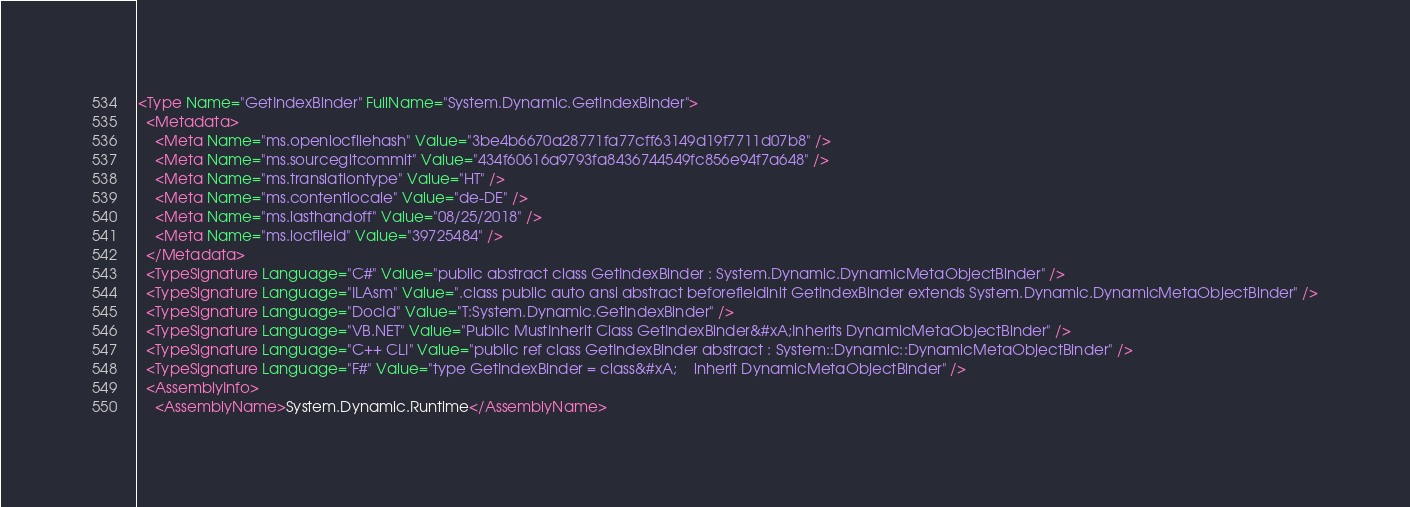Convert code to text. <code><loc_0><loc_0><loc_500><loc_500><_XML_><Type Name="GetIndexBinder" FullName="System.Dynamic.GetIndexBinder">
  <Metadata>
    <Meta Name="ms.openlocfilehash" Value="3be4b6670a28771fa77cff63149d19f7711d07b8" />
    <Meta Name="ms.sourcegitcommit" Value="434f60616a9793fa8436744549fc856e94f7a648" />
    <Meta Name="ms.translationtype" Value="HT" />
    <Meta Name="ms.contentlocale" Value="de-DE" />
    <Meta Name="ms.lasthandoff" Value="08/25/2018" />
    <Meta Name="ms.locfileid" Value="39725484" />
  </Metadata>
  <TypeSignature Language="C#" Value="public abstract class GetIndexBinder : System.Dynamic.DynamicMetaObjectBinder" />
  <TypeSignature Language="ILAsm" Value=".class public auto ansi abstract beforefieldinit GetIndexBinder extends System.Dynamic.DynamicMetaObjectBinder" />
  <TypeSignature Language="DocId" Value="T:System.Dynamic.GetIndexBinder" />
  <TypeSignature Language="VB.NET" Value="Public MustInherit Class GetIndexBinder&#xA;Inherits DynamicMetaObjectBinder" />
  <TypeSignature Language="C++ CLI" Value="public ref class GetIndexBinder abstract : System::Dynamic::DynamicMetaObjectBinder" />
  <TypeSignature Language="F#" Value="type GetIndexBinder = class&#xA;    inherit DynamicMetaObjectBinder" />
  <AssemblyInfo>
    <AssemblyName>System.Dynamic.Runtime</AssemblyName></code> 